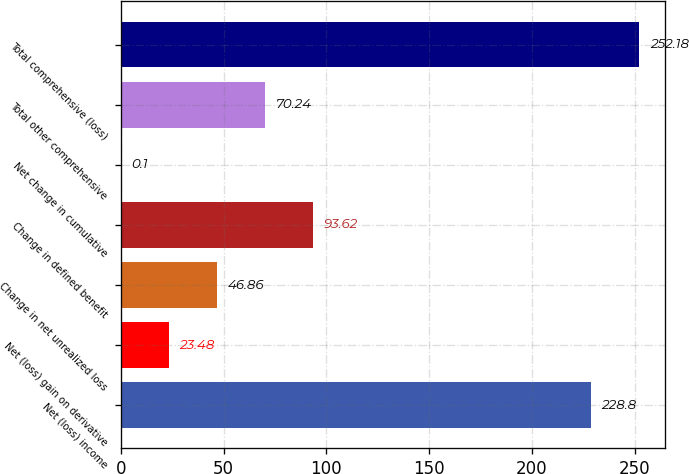Convert chart to OTSL. <chart><loc_0><loc_0><loc_500><loc_500><bar_chart><fcel>Net (loss) income<fcel>Net (loss) gain on derivative<fcel>Change in net unrealized loss<fcel>Change in defined benefit<fcel>Net change in cumulative<fcel>Total other comprehensive<fcel>Total comprehensive (loss)<nl><fcel>228.8<fcel>23.48<fcel>46.86<fcel>93.62<fcel>0.1<fcel>70.24<fcel>252.18<nl></chart> 